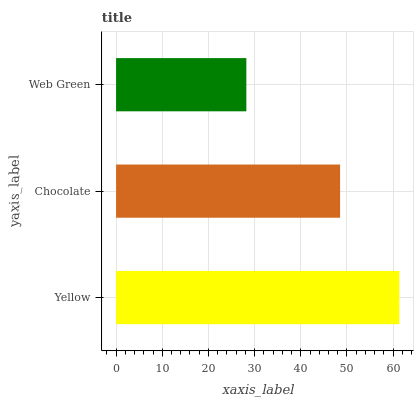Is Web Green the minimum?
Answer yes or no. Yes. Is Yellow the maximum?
Answer yes or no. Yes. Is Chocolate the minimum?
Answer yes or no. No. Is Chocolate the maximum?
Answer yes or no. No. Is Yellow greater than Chocolate?
Answer yes or no. Yes. Is Chocolate less than Yellow?
Answer yes or no. Yes. Is Chocolate greater than Yellow?
Answer yes or no. No. Is Yellow less than Chocolate?
Answer yes or no. No. Is Chocolate the high median?
Answer yes or no. Yes. Is Chocolate the low median?
Answer yes or no. Yes. Is Yellow the high median?
Answer yes or no. No. Is Yellow the low median?
Answer yes or no. No. 